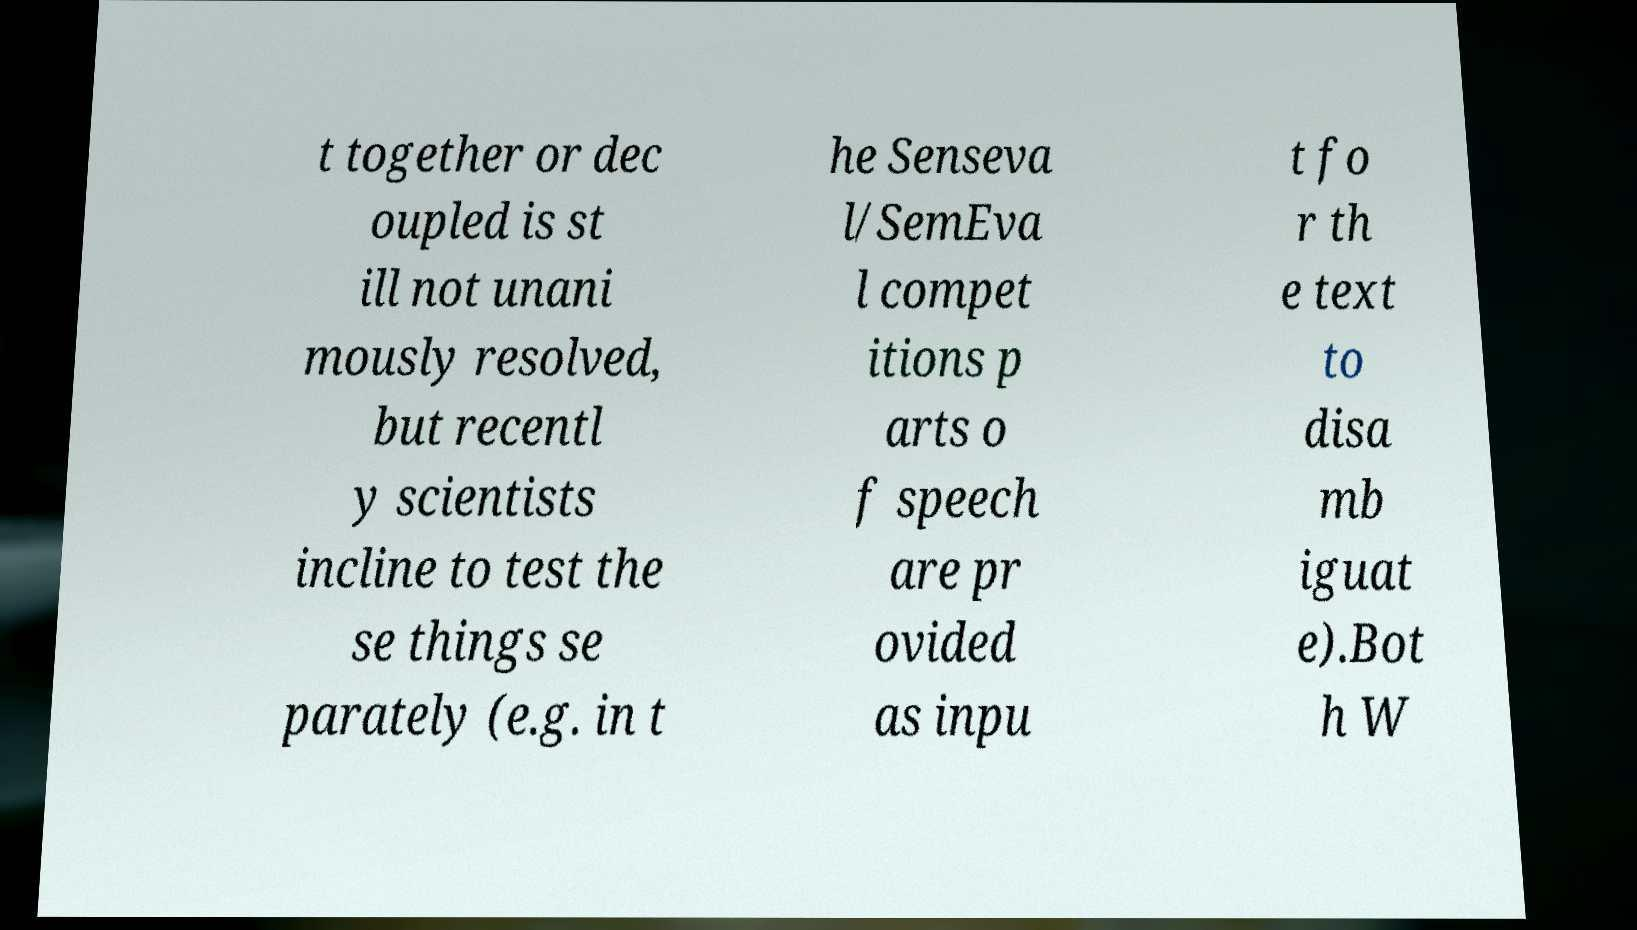Can you read and provide the text displayed in the image?This photo seems to have some interesting text. Can you extract and type it out for me? t together or dec oupled is st ill not unani mously resolved, but recentl y scientists incline to test the se things se parately (e.g. in t he Senseva l/SemEva l compet itions p arts o f speech are pr ovided as inpu t fo r th e text to disa mb iguat e).Bot h W 